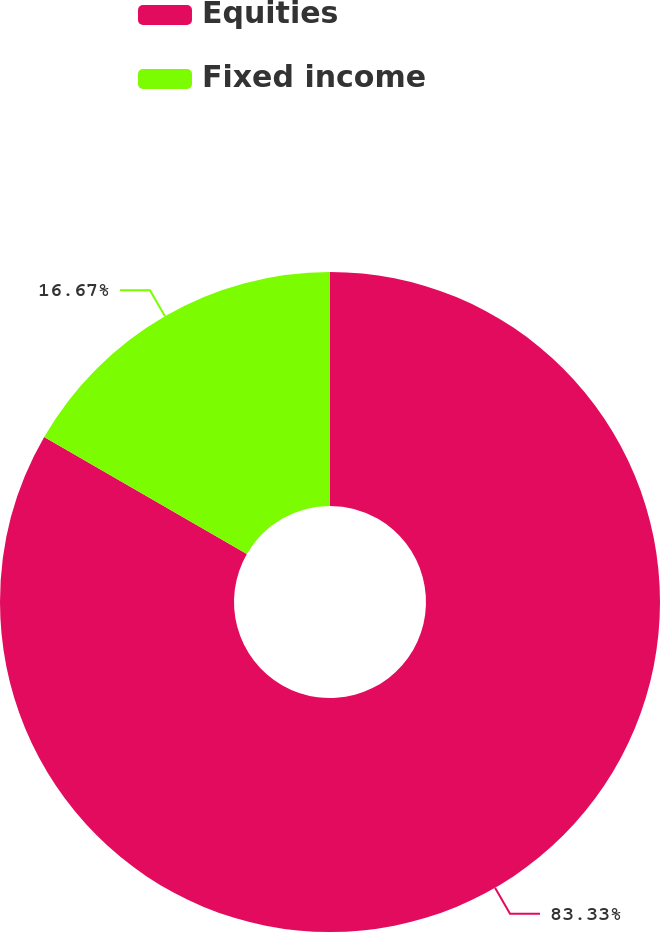<chart> <loc_0><loc_0><loc_500><loc_500><pie_chart><fcel>Equities<fcel>Fixed income<nl><fcel>83.33%<fcel>16.67%<nl></chart> 